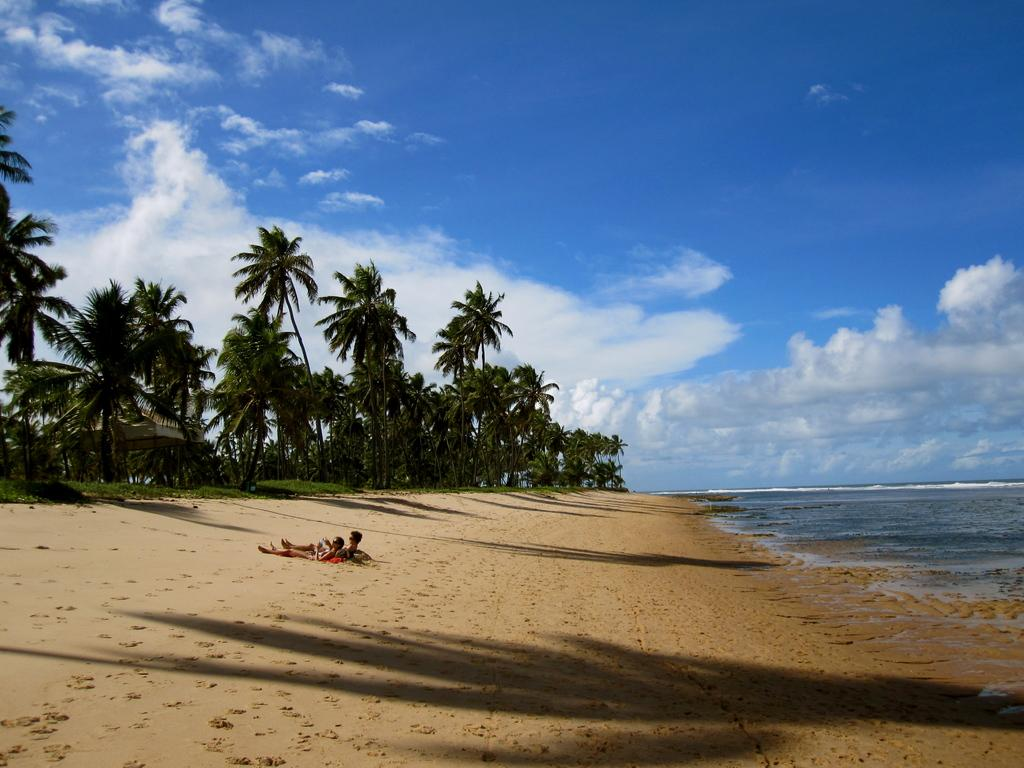How many people are in the image? There are two people in the image. What are the people doing in the image? The people are laying on a beach. What can be seen in the background of the image? There are trees and the sky visible in the background of the image. What is on the right side of the image? There is a sea on the right side of the image. What type of honey is being collected by the people in the image? There is no honey or honey collection activity present in the image. 